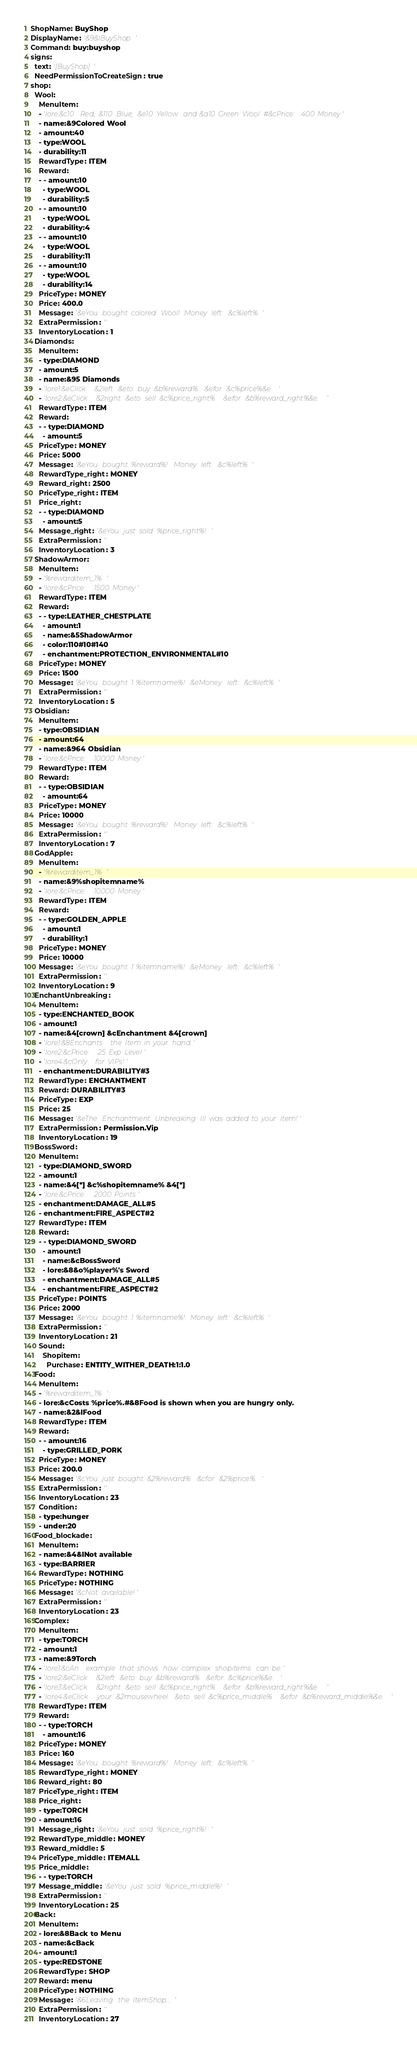<code> <loc_0><loc_0><loc_500><loc_500><_YAML_>ShopName: BuyShop
DisplayName: '&9&lBuyShop'
Command: buy:buyshop
signs:
  text: '[BuyShop]'
  NeedPermissionToCreateSign: true
shop:
  Wool:
    MenuItem:
    - 'lore:&c10 Red, &110 Blue, &e10 Yellow and &a10 Green Wool #&cPrice: 400 Money'
    - name:&9Colored Wool
    - amount:40
    - type:WOOL
    - durability:11
    RewardType: ITEM
    Reward:
    - - amount:10
      - type:WOOL
      - durability:5
    - - amount:10
      - type:WOOL
      - durability:4
    - - amount:10
      - type:WOOL
      - durability:11
    - - amount:10
      - type:WOOL
      - durability:14
    PriceType: MONEY
    Price: 400.0
    Message: '&eYou bought colored Wool! Money left: &c%left%'
    ExtraPermission: ''
    InventoryLocation: 1
  Diamonds:
    MenuItem:
    - type:DIAMOND
    - amount:5
    - name:&95 Diamonds
    - 'lore1:&eClick &2left &eto buy &b%reward% &efor &c%price%&e.'
    - 'lore2:&eClick &2right &eto sell &c%price_right% &efor &b%reward_right%&e.'
    RewardType: ITEM
    Reward:
    - - type:DIAMOND
      - amount:5
    PriceType: MONEY
    Price: 5000
    Message: '&eYou bought %reward%! Money left: &c%left%'
    RewardType_right: MONEY
    Reward_right: 2500
    PriceType_right: ITEM
    Price_right:
    - - type:DIAMOND
      - amount:5
    Message_right: '&eYou just sold %price_right%!'
    ExtraPermission: ''
    InventoryLocation: 3
  ShadowArmor:
    MenuItem:
    - '%rewarditem_1%'
    - 'lore:&cPrice: 1500 Money'
    RewardType: ITEM
    Reward:
    - - type:LEATHER_CHESTPLATE
      - amount:1
      - name:&5ShadowArmor
      - color:110#10#140
      - enchantment:PROTECTION_ENVIRONMENTAL#10
    PriceType: MONEY
    Price: 1500
    Message: '&eYou bought 1 %itemname%! &eMoney left: &c%left%'
    ExtraPermission: ''
    InventoryLocation: 5
  Obsidian:
    MenuItem:
    - type:OBSIDIAN
    - amount:64
    - name:&964 Obsidian
    - 'lore:&cPrice: 10000 Money'
    RewardType: ITEM
    Reward:
    - - type:OBSIDIAN
      - amount:64
    PriceType: MONEY
    Price: 10000
    Message: '&eYou bought %reward%! Money left: &c%left%'
    ExtraPermission: ''
    InventoryLocation: 7
  GodApple:
    MenuItem:
    - '%rewarditem_1%'
    - name:&9%shopitemname%
    - 'lore:&cPrice: 10000 Money'
    RewardType: ITEM
    Reward:
    - - type:GOLDEN_APPLE
      - amount:1
      - durability:1
    PriceType: MONEY
    Price: 10000
    Message: '&eYou bought 1 %itemname%! &eMoney left: &c%left%'
    ExtraPermission: ''
    InventoryLocation: 9
  EnchantUnbreaking:
    MenuItem:
    - type:ENCHANTED_BOOK
    - amount:1
    - name:&4[crown] &cEnchantment &4[crown]
    - 'lore1:&8Enchants the Item in your hand.'
    - 'lore2:&cPrice: 25 Exp Level'
    - 'lore4:&cOnly for VIPs!'
    - enchantment:DURABILITY#3
    RewardType: ENCHANTMENT
    Reward: DURABILITY#3
    PriceType: EXP
    Price: 25
    Message: '&eThe Enchantment Unbreaking III was added to your item!'
    ExtraPermission: Permission.Vip
    InventoryLocation: 19
  BossSword:
    MenuItem:
    - type:DIAMOND_SWORD
    - amount:1
    - name:&4[*] &c%shopitemname% &4[*]
    - 'lore:&cPrice: 2000 Points'
    - enchantment:DAMAGE_ALL#5
    - enchantment:FIRE_ASPECT#2
    RewardType: ITEM
    Reward:
    - - type:DIAMOND_SWORD
      - amount:1
      - name:&cBossSword
      - lore:&8&o%player%'s Sword
      - enchantment:DAMAGE_ALL#5
      - enchantment:FIRE_ASPECT#2
    PriceType: POINTS
    Price: 2000
    Message: '&eYou bought 1 %itemname%! Money left: &c%left%'
    ExtraPermission: ''
    InventoryLocation: 21
    Sound:
      Shopitem:
        Purchase: ENTITY_WITHER_DEATH:1:1.0
  Food:
    MenuItem:
    - '%rewarditem_1%'
    - lore:&cCosts %price%.#&8Food is shown when you are hungry only.
    - name:&2&lFood
    RewardType: ITEM
    Reward:
    - - amount:16
      - type:GRILLED_PORK
    PriceType: MONEY
    Price: 200.0
    Message: '&cYou just bought &2%reward% &cfor &2%price%.'
    ExtraPermission: ''
    InventoryLocation: 23
    Condition:
    - type:hunger
    - under:20
  Food_blockade:
    MenuItem:
    - name:&4&lNot available
    - type:BARRIER
    RewardType: NOTHING
    PriceType: NOTHING
    Message: '&cNot available!'
    ExtraPermission: ''
    InventoryLocation: 23
  Complex:
    MenuItem:
    - type:TORCH
    - amount:1
    - name:&9Torch
    - 'lore1:&cAn example that shows how complex shopitems can be.'
    - 'lore2:&eClick &2left &eto buy &b%reward% &efor &c%price%&e.'
    - 'lore3:&eClick &2right &eto sell &c%price_right% &efor &b%reward_right%&e.'
    - 'lore4:&eClick your &2mousewheel &eto sell &c%price_middle% &efor &b%reward_middle%&e.'
    RewardType: ITEM
    Reward:
    - - type:TORCH
      - amount:16
    PriceType: MONEY
    Price: 160
    Message: '&eYou bought %reward%! Money left: &c%left%'
    RewardType_right: MONEY
    Reward_right: 80
    PriceType_right: ITEM
    Price_right:
    - type:TORCH
    - amount:16
    Message_right: '&eYou just sold %price_right%!'
    RewardType_middle: MONEY
    Reward_middle: 5
    PriceType_middle: ITEMALL
    Price_middle:
    - - type:TORCH
    Message_middle: '&eYou just sold %price_middle%!'
    ExtraPermission: ''
    InventoryLocation: 25
  Back:
    MenuItem:
    - lore:&8Back to Menu
    - name:&cBack
    - amount:1
    - type:REDSTONE
    RewardType: SHOP
    Reward: menu
    PriceType: NOTHING
    Message: '&6Leaving the ItemShop...'
    ExtraPermission: ''
    InventoryLocation: 27
</code> 